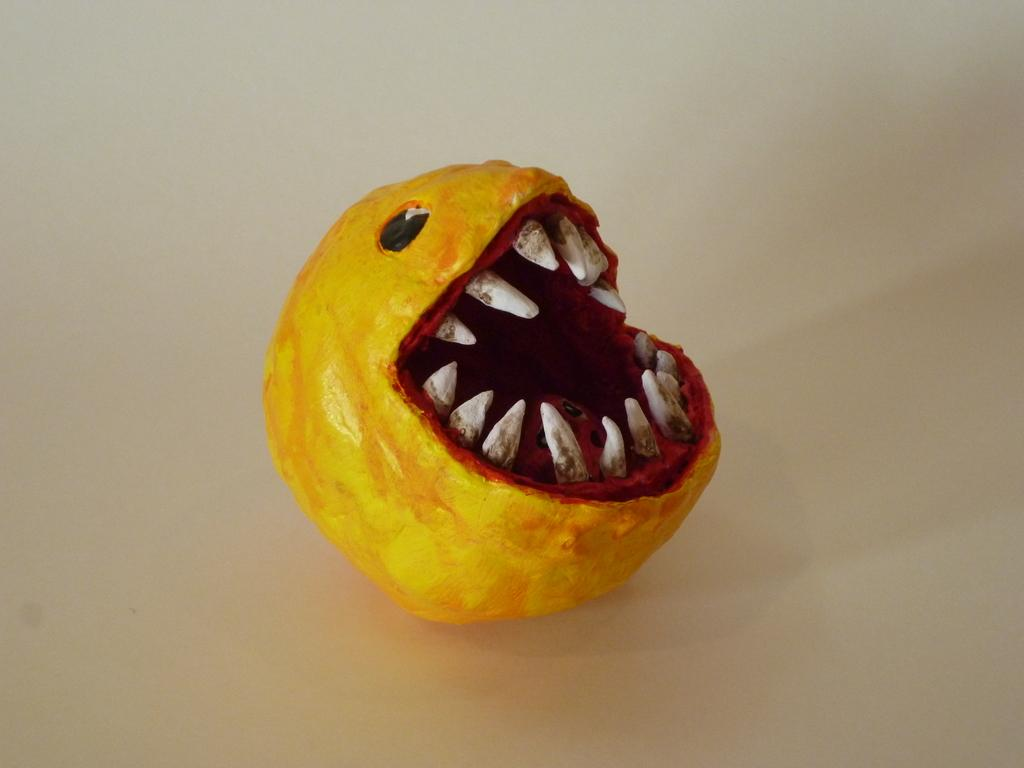What color is the prominent object in the image? The prominent object in the image is yellow-colored. Can you hear the owl hooting in the image? There is no owl present in the image, so it cannot be heard hooting. What type of cord is connected to the yellow object in the image? There is no cord connected to the yellow object in the image. 